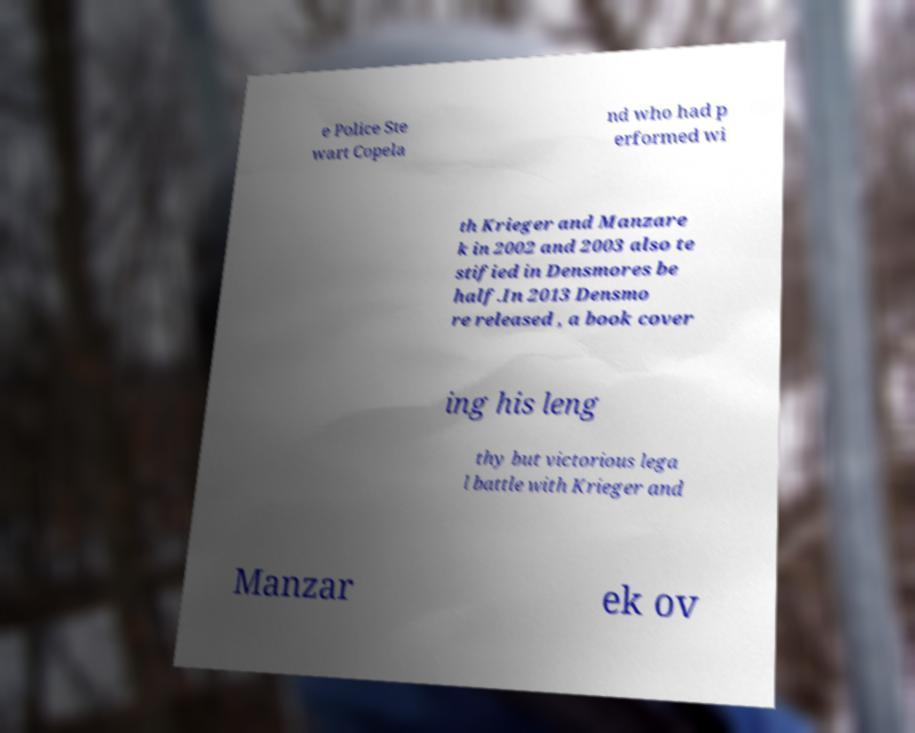Could you extract and type out the text from this image? e Police Ste wart Copela nd who had p erformed wi th Krieger and Manzare k in 2002 and 2003 also te stified in Densmores be half.In 2013 Densmo re released , a book cover ing his leng thy but victorious lega l battle with Krieger and Manzar ek ov 